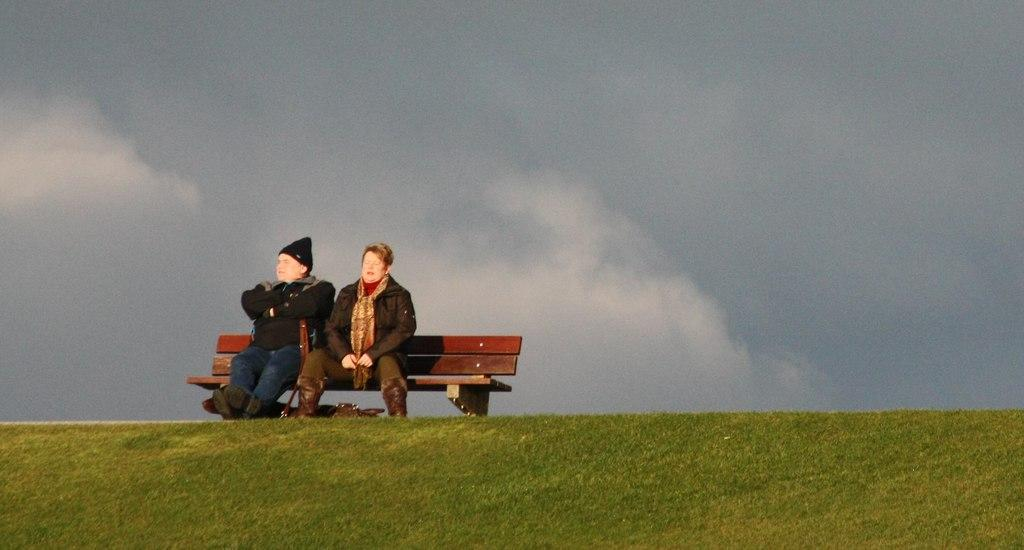What type of surface is at the bottom of the image? There is grass at the bottom of the image. What are the two persons doing in the image? The two persons are sitting on a bench in the middle of the image. What is the condition of the sky in the background? The sky in the background is cloudy. What color is the bead that one of the persons is wearing in the image? There is no bead visible in the image; the persons are not wearing any accessories. 